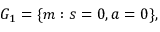Convert formula to latex. <formula><loc_0><loc_0><loc_500><loc_500>G _ { 1 } = \{ m \colon s = 0 , a = 0 \} ,</formula> 